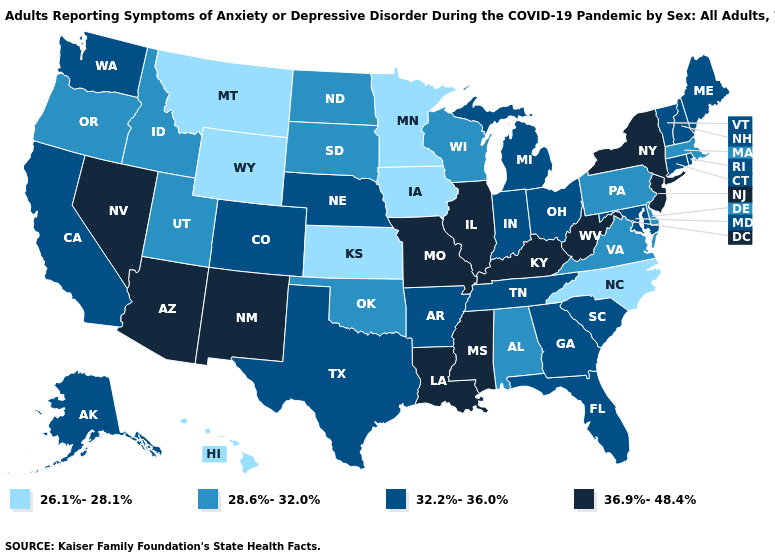What is the value of Oklahoma?
Keep it brief. 28.6%-32.0%. Name the states that have a value in the range 36.9%-48.4%?
Give a very brief answer. Arizona, Illinois, Kentucky, Louisiana, Mississippi, Missouri, Nevada, New Jersey, New Mexico, New York, West Virginia. Name the states that have a value in the range 32.2%-36.0%?
Write a very short answer. Alaska, Arkansas, California, Colorado, Connecticut, Florida, Georgia, Indiana, Maine, Maryland, Michigan, Nebraska, New Hampshire, Ohio, Rhode Island, South Carolina, Tennessee, Texas, Vermont, Washington. Name the states that have a value in the range 28.6%-32.0%?
Answer briefly. Alabama, Delaware, Idaho, Massachusetts, North Dakota, Oklahoma, Oregon, Pennsylvania, South Dakota, Utah, Virginia, Wisconsin. Among the states that border Pennsylvania , which have the lowest value?
Give a very brief answer. Delaware. Which states have the highest value in the USA?
Keep it brief. Arizona, Illinois, Kentucky, Louisiana, Mississippi, Missouri, Nevada, New Jersey, New Mexico, New York, West Virginia. What is the highest value in states that border Texas?
Quick response, please. 36.9%-48.4%. What is the value of Maine?
Write a very short answer. 32.2%-36.0%. What is the value of Maine?
Keep it brief. 32.2%-36.0%. What is the value of Montana?
Give a very brief answer. 26.1%-28.1%. Name the states that have a value in the range 32.2%-36.0%?
Answer briefly. Alaska, Arkansas, California, Colorado, Connecticut, Florida, Georgia, Indiana, Maine, Maryland, Michigan, Nebraska, New Hampshire, Ohio, Rhode Island, South Carolina, Tennessee, Texas, Vermont, Washington. Does Utah have a lower value than Iowa?
Quick response, please. No. Which states have the lowest value in the South?
Concise answer only. North Carolina. Among the states that border Oklahoma , which have the highest value?
Be succinct. Missouri, New Mexico. Among the states that border Michigan , which have the highest value?
Answer briefly. Indiana, Ohio. 